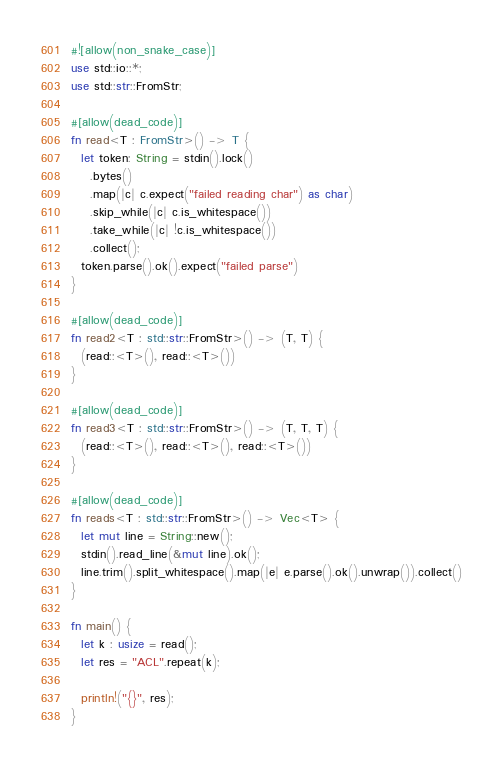Convert code to text. <code><loc_0><loc_0><loc_500><loc_500><_Rust_>#![allow(non_snake_case)]
use std::io::*;
use std::str::FromStr;

#[allow(dead_code)]
fn read<T : FromStr>() -> T {
  let token: String = stdin().lock()
    .bytes()
    .map(|c| c.expect("failed reading char") as char)
    .skip_while(|c| c.is_whitespace())
    .take_while(|c| !c.is_whitespace())
    .collect();
  token.parse().ok().expect("failed parse")
}

#[allow(dead_code)]
fn read2<T : std::str::FromStr>() -> (T, T) {
  (read::<T>(), read::<T>())
}

#[allow(dead_code)]
fn read3<T : std::str::FromStr>() -> (T, T, T) {
  (read::<T>(), read::<T>(), read::<T>())
}

#[allow(dead_code)]
fn reads<T : std::str::FromStr>() -> Vec<T> {
  let mut line = String::new();
  stdin().read_line(&mut line).ok();
  line.trim().split_whitespace().map(|e| e.parse().ok().unwrap()).collect()
}

fn main() {
  let k : usize = read();
  let res = "ACL".repeat(k);

  println!("{}", res);
}</code> 